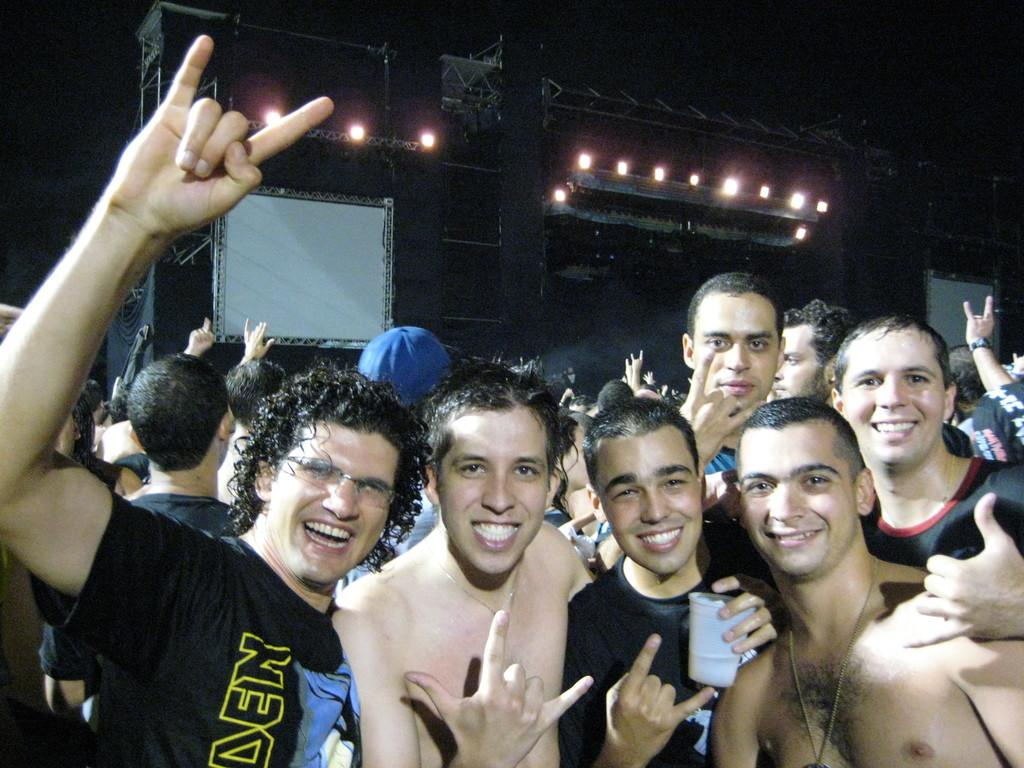How many people are present in the image? There are many people in the image. What is one person holding in the image? One person is holding a glass. Can you describe the eyewear of one of the people in the image? Another person is wearing glasses (specs). What can be seen in the background of the image? There is a board in the background of the image. What is visible in the image that provides illumination? There are lights visible in the image. How long does it take for the bee to fly across the image? There is no bee present in the image, so it is not possible to determine how long it would take for a bee to fly across the image. 